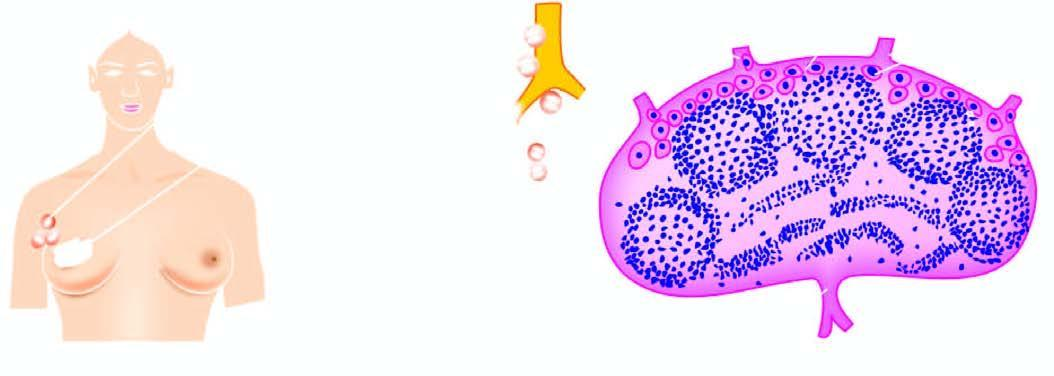what does lymphatic spread begin by?
Answer the question using a single word or phrase. Lodgement of tumour cells 